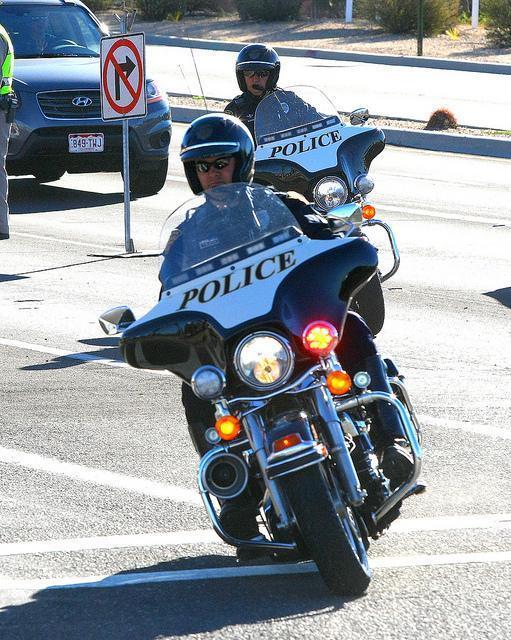How many people are there?
Give a very brief answer. 2. How many motorcycles are in the picture?
Give a very brief answer. 2. 